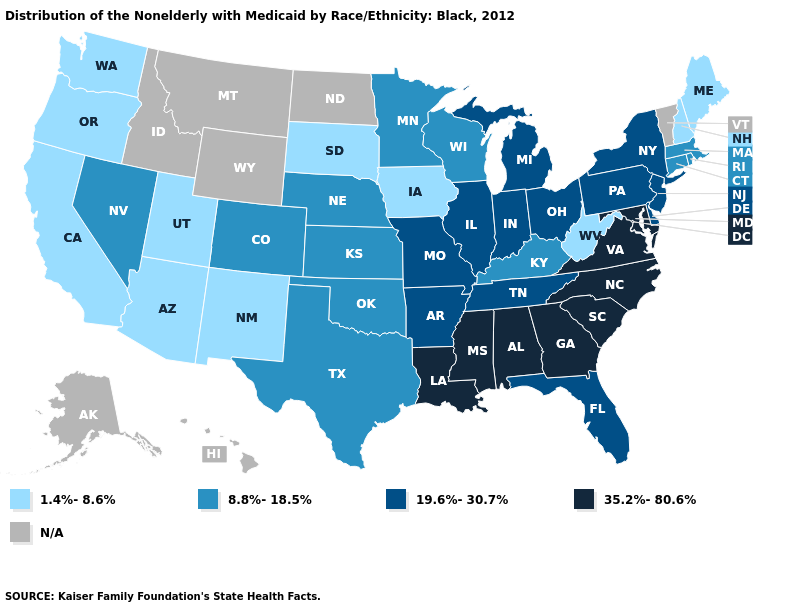What is the value of Oregon?
Keep it brief. 1.4%-8.6%. Name the states that have a value in the range N/A?
Answer briefly. Alaska, Hawaii, Idaho, Montana, North Dakota, Vermont, Wyoming. Does Louisiana have the highest value in the USA?
Write a very short answer. Yes. Does the map have missing data?
Give a very brief answer. Yes. Name the states that have a value in the range 1.4%-8.6%?
Give a very brief answer. Arizona, California, Iowa, Maine, New Hampshire, New Mexico, Oregon, South Dakota, Utah, Washington, West Virginia. Among the states that border Minnesota , does Wisconsin have the lowest value?
Answer briefly. No. Name the states that have a value in the range 19.6%-30.7%?
Answer briefly. Arkansas, Delaware, Florida, Illinois, Indiana, Michigan, Missouri, New Jersey, New York, Ohio, Pennsylvania, Tennessee. Among the states that border Illinois , does Iowa have the lowest value?
Keep it brief. Yes. Which states have the highest value in the USA?
Quick response, please. Alabama, Georgia, Louisiana, Maryland, Mississippi, North Carolina, South Carolina, Virginia. Which states have the lowest value in the USA?
Quick response, please. Arizona, California, Iowa, Maine, New Hampshire, New Mexico, Oregon, South Dakota, Utah, Washington, West Virginia. What is the value of Arkansas?
Answer briefly. 19.6%-30.7%. What is the value of Arizona?
Be succinct. 1.4%-8.6%. What is the lowest value in states that border Washington?
Be succinct. 1.4%-8.6%. What is the value of Maryland?
Concise answer only. 35.2%-80.6%. 